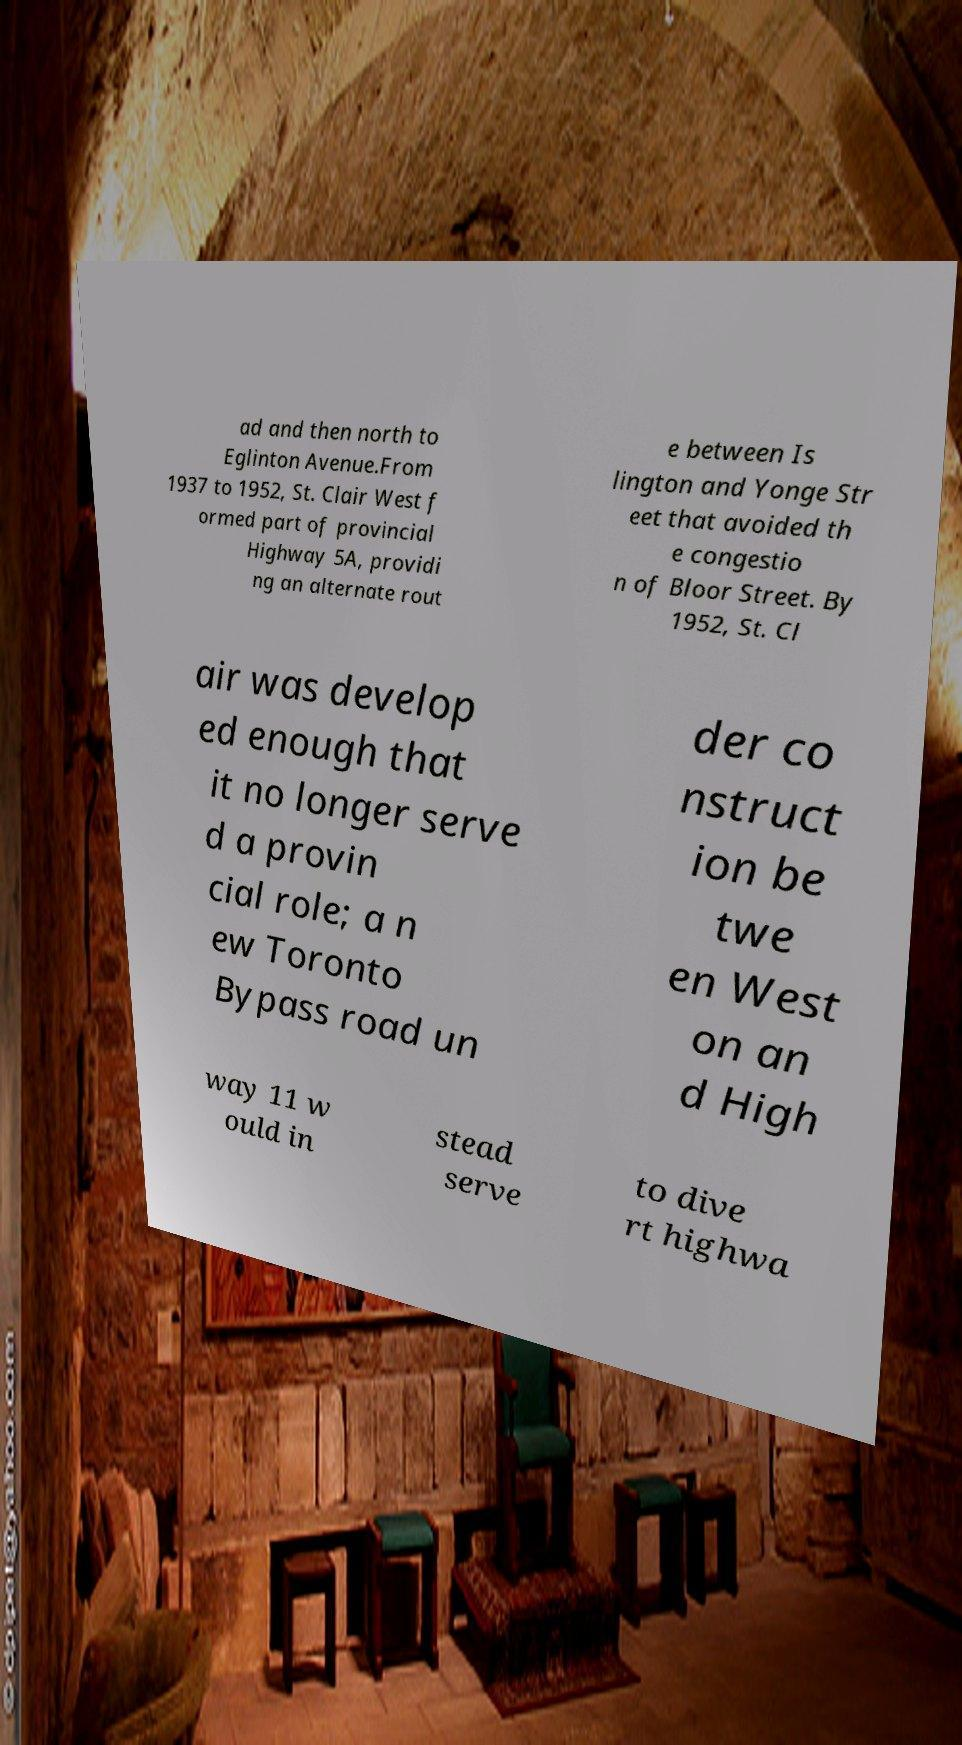Can you accurately transcribe the text from the provided image for me? ad and then north to Eglinton Avenue.From 1937 to 1952, St. Clair West f ormed part of provincial Highway 5A, providi ng an alternate rout e between Is lington and Yonge Str eet that avoided th e congestio n of Bloor Street. By 1952, St. Cl air was develop ed enough that it no longer serve d a provin cial role; a n ew Toronto Bypass road un der co nstruct ion be twe en West on an d High way 11 w ould in stead serve to dive rt highwa 